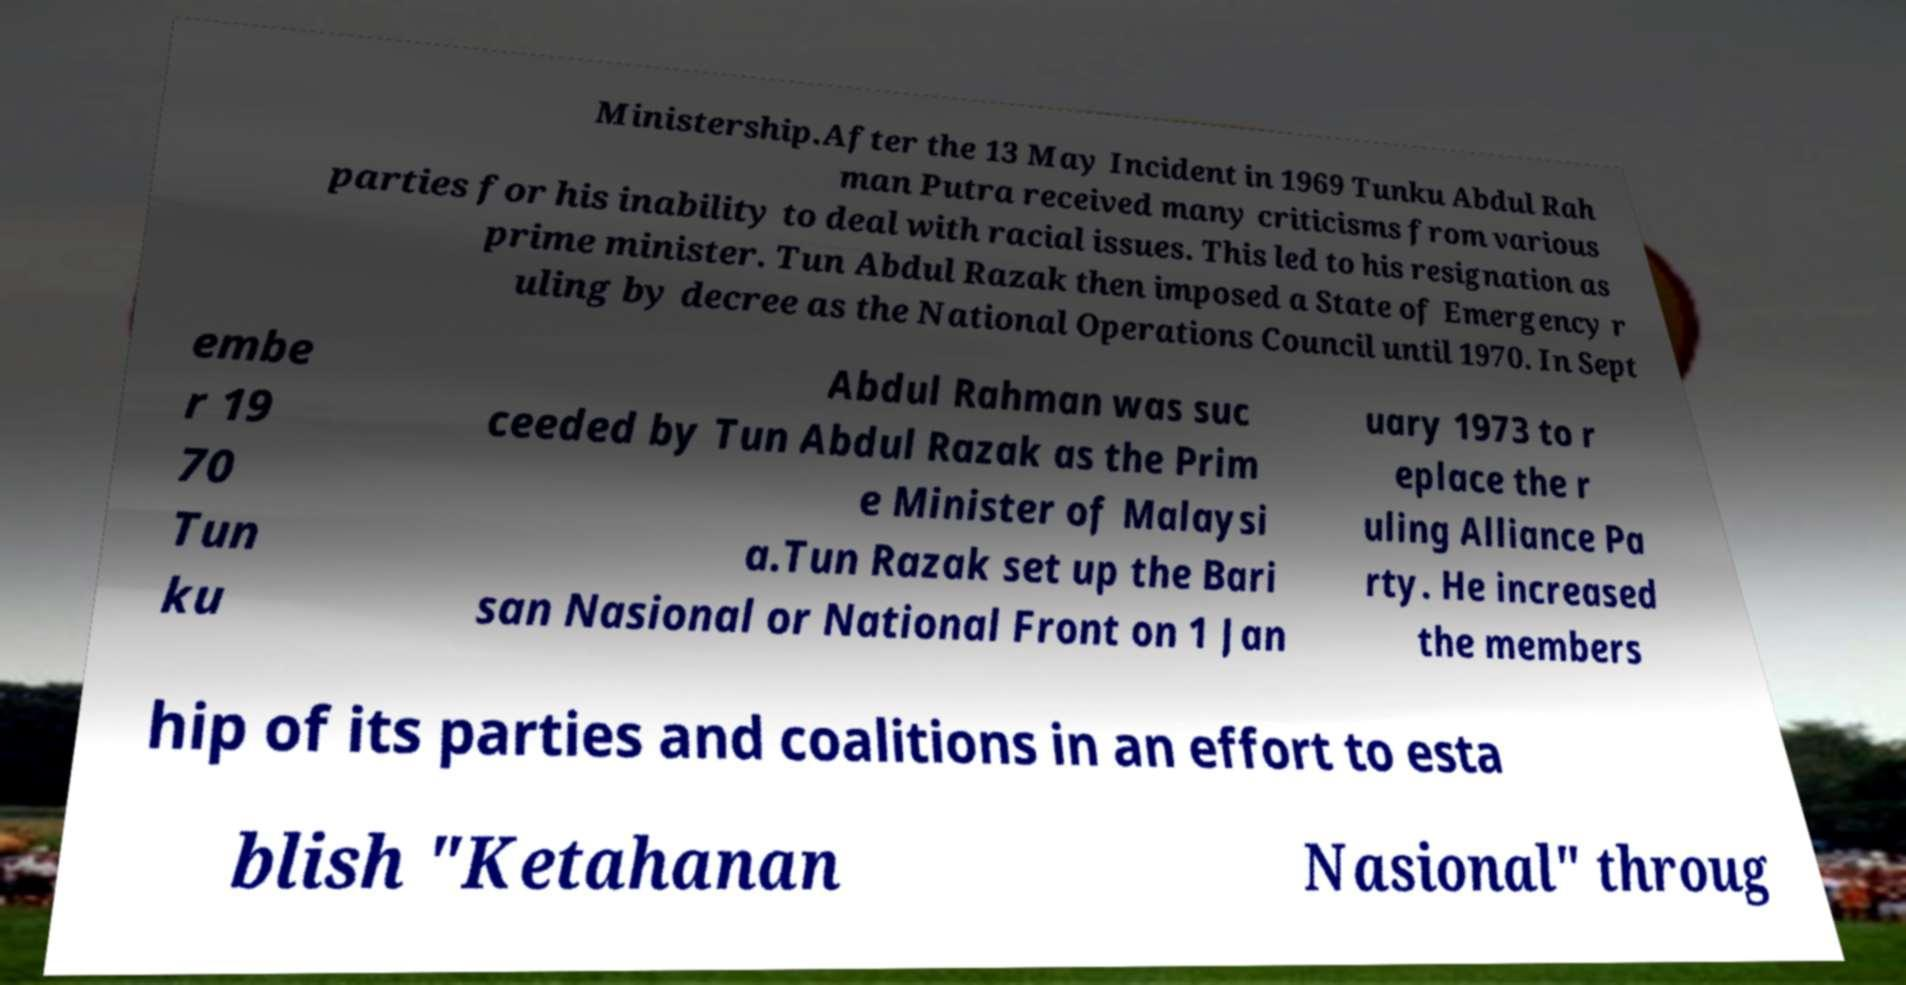Please identify and transcribe the text found in this image. Ministership.After the 13 May Incident in 1969 Tunku Abdul Rah man Putra received many criticisms from various parties for his inability to deal with racial issues. This led to his resignation as prime minister. Tun Abdul Razak then imposed a State of Emergency r uling by decree as the National Operations Council until 1970. In Sept embe r 19 70 Tun ku Abdul Rahman was suc ceeded by Tun Abdul Razak as the Prim e Minister of Malaysi a.Tun Razak set up the Bari san Nasional or National Front on 1 Jan uary 1973 to r eplace the r uling Alliance Pa rty. He increased the members hip of its parties and coalitions in an effort to esta blish "Ketahanan Nasional" throug 